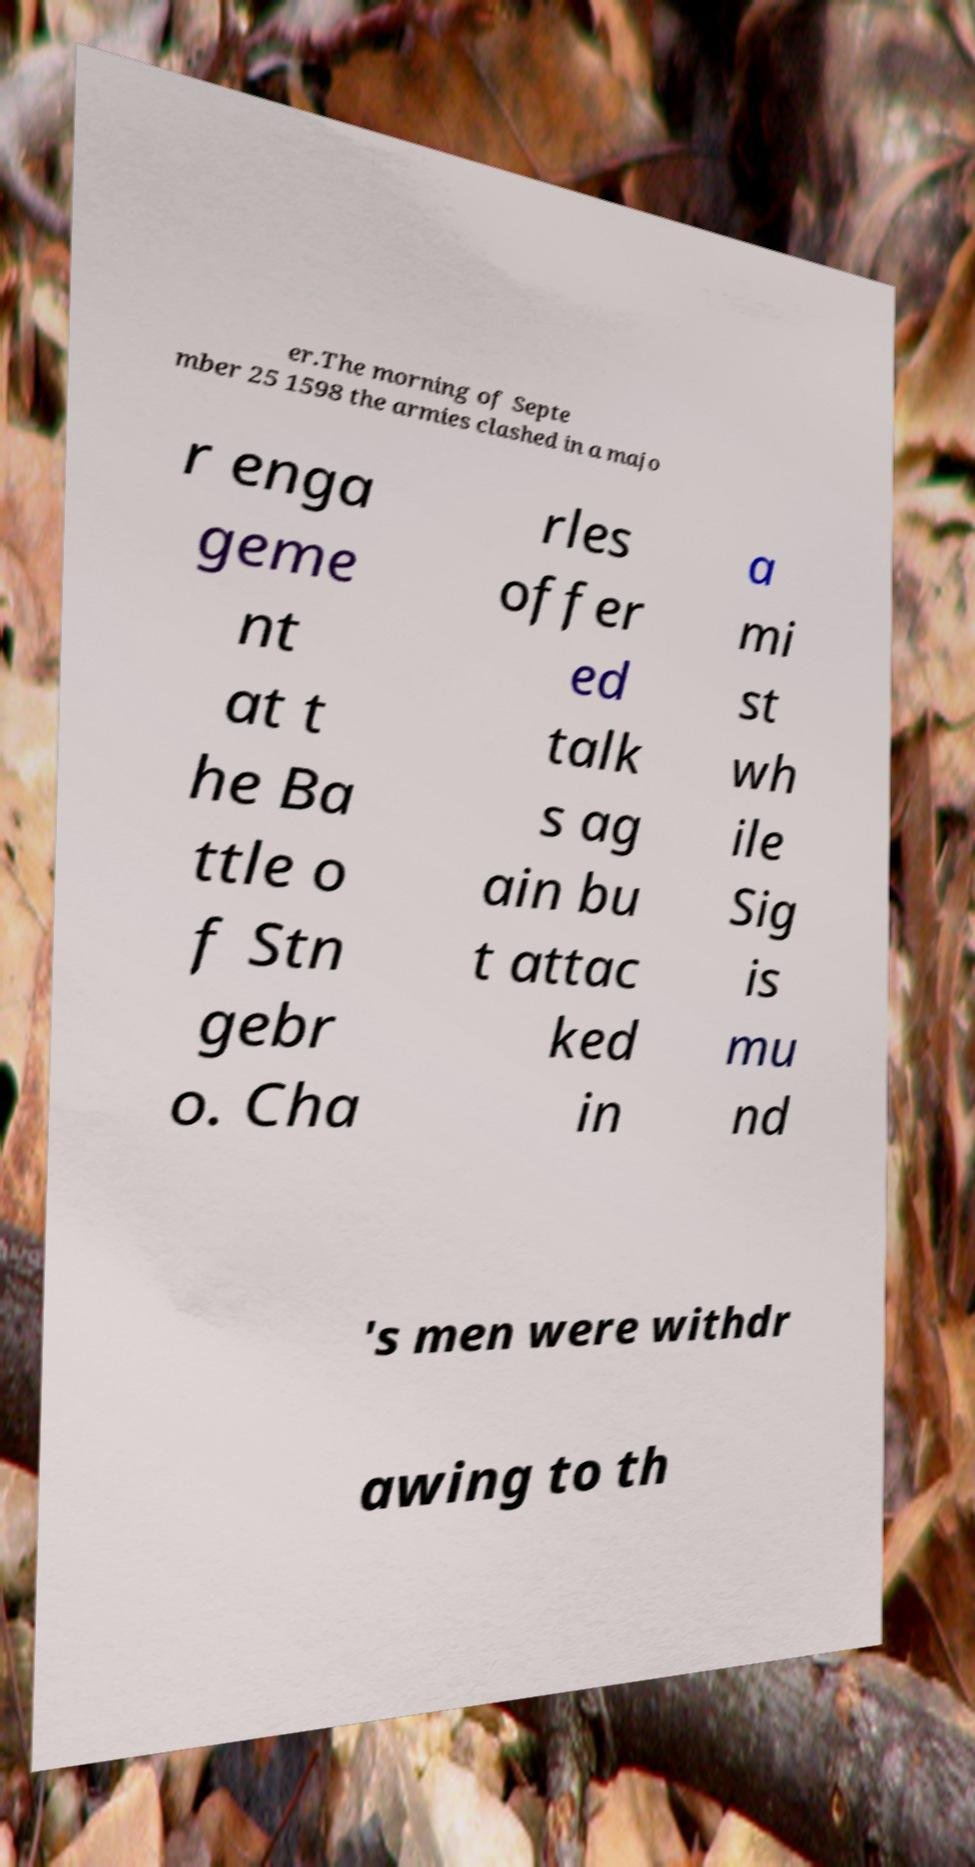Please identify and transcribe the text found in this image. er.The morning of Septe mber 25 1598 the armies clashed in a majo r enga geme nt at t he Ba ttle o f Stn gebr o. Cha rles offer ed talk s ag ain bu t attac ked in a mi st wh ile Sig is mu nd 's men were withdr awing to th 